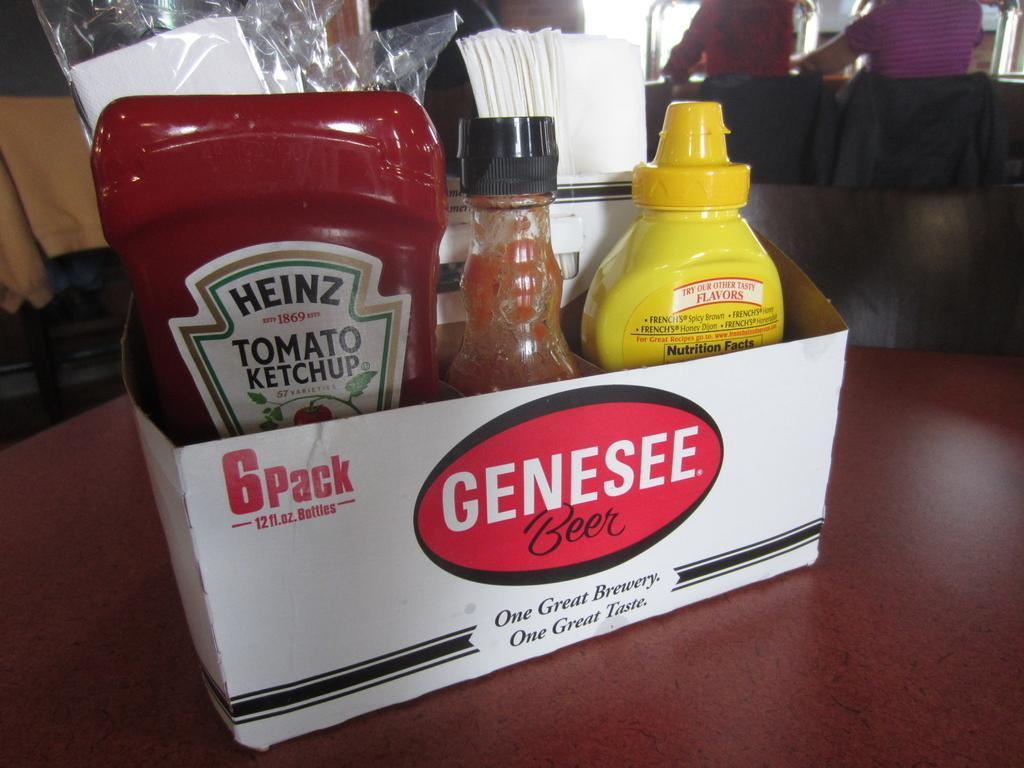<image>
Present a compact description of the photo's key features. the word genesee that is on a box item 